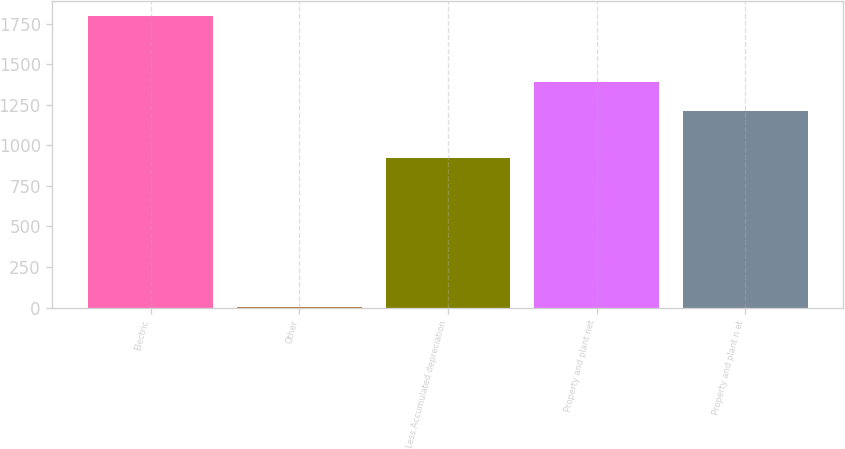<chart> <loc_0><loc_0><loc_500><loc_500><bar_chart><fcel>Electric<fcel>Other<fcel>Less Accumulated depreciation<fcel>Property and plant net<fcel>Property and plant n et<nl><fcel>1796<fcel>6<fcel>923<fcel>1391<fcel>1212<nl></chart> 